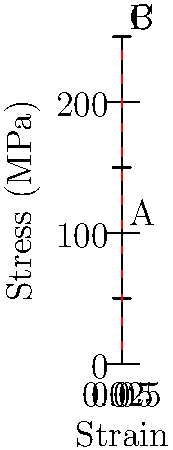In the context of ancient Roman engineering, consider the stress-strain curve for a typical structural steel specimen used in modern construction, as shown in the graph. How might this knowledge of material properties have influenced the design and construction of large-scale Roman structures like aqueducts or amphitheaters? Identify the yield point (A), ultimate strength point (B), and failure point (C) on the curve, and explain how understanding these points could have potentially improved ancient Roman construction techniques. To answer this question, let's break down the stress-strain curve and relate it to ancient Roman engineering:

1. Yield point (A):
   - Located at approximately (0.002, 100) on the graph
   - Represents the end of the elastic region and the beginning of plastic deformation
   - Ancient Romans didn't have this precise knowledge, but they understood the concept of elasticity in materials

2. Ultimate strength point (B):
   - Located at approximately (0.015, 250) on the graph
   - Represents the maximum stress the material can withstand
   - Romans empirically determined the strength of their materials through trial and error

3. Failure point (C):
   - Located at (0.05, 250) on the graph
   - Represents the point at which the material fails completely
   - Romans understood the concept of material failure and designed structures with safety factors

Understanding these points could have improved ancient Roman construction techniques in several ways:

a) Optimal material usage: Knowing the yield point would allow for more efficient use of materials, potentially reducing costs and weight in structures like aqueducts.

b) Safety improvements: Understanding the ultimate strength and failure points would enable better estimation of safety factors, leading to more reliable structures like amphitheaters.

c) Innovative designs: With a deeper understanding of material properties, Romans might have developed even more advanced architectural techniques, possibly leading to taller or more complex structures.

d) Maintenance and longevity: Knowledge of how materials behave under stress could have informed better maintenance practices, potentially extending the lifespan of structures.

e) Adaptation to different materials: This understanding could have been applied to other construction materials like stone or concrete, leading to more refined building techniques across various projects.

While the Romans didn't have access to this precise scientific knowledge, they developed impressive engineering skills through practical experience and observation. Modern understanding of stress-strain relationships helps us appreciate the ingenuity of ancient Roman engineers and the potential for further advancements had they possessed this knowledge.
Answer: Understanding material properties could have led to more efficient material use, improved safety factors, innovative designs, better maintenance practices, and refined building techniques in ancient Roman engineering. 